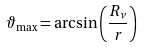<formula> <loc_0><loc_0><loc_500><loc_500>\vartheta _ { \max } = \arcsin \left ( \frac { R _ { \nu } } { r } \right )</formula> 